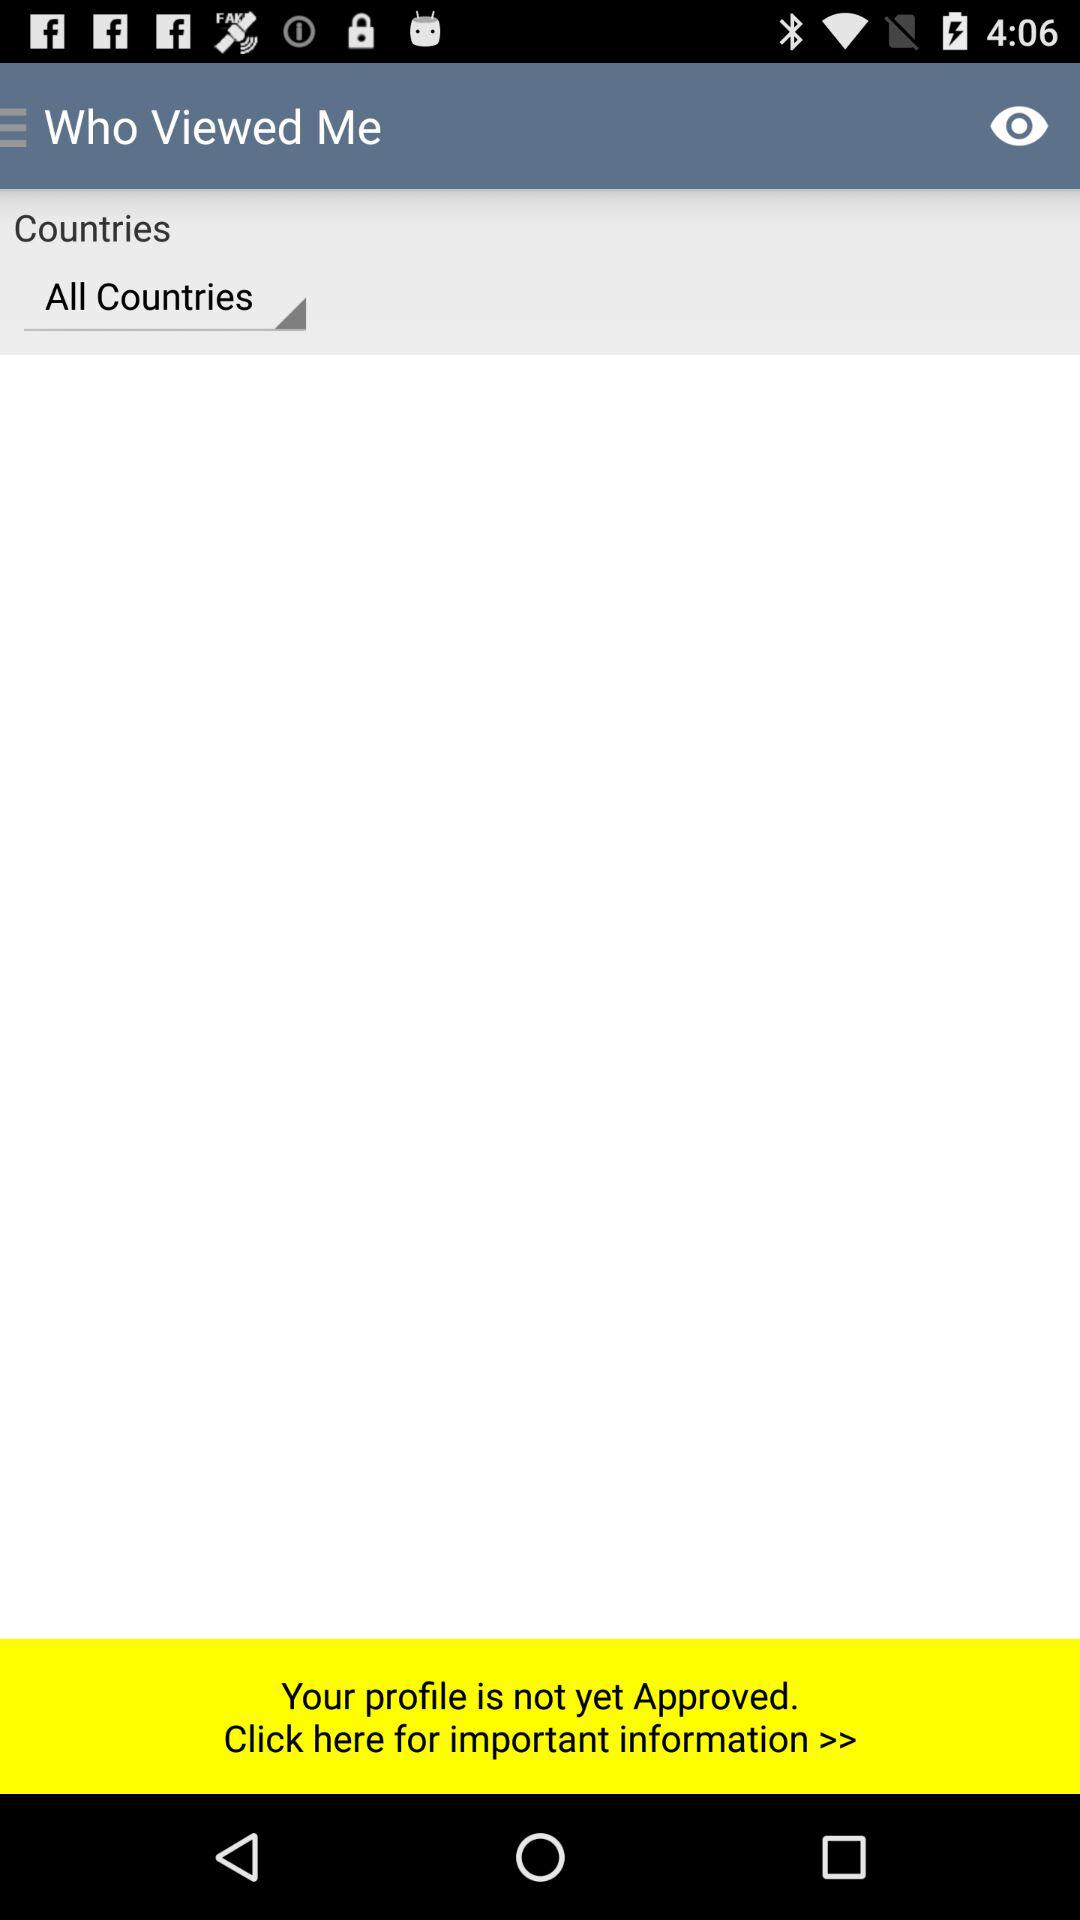What are the current selected countries? The selected countries are "All Countries". 